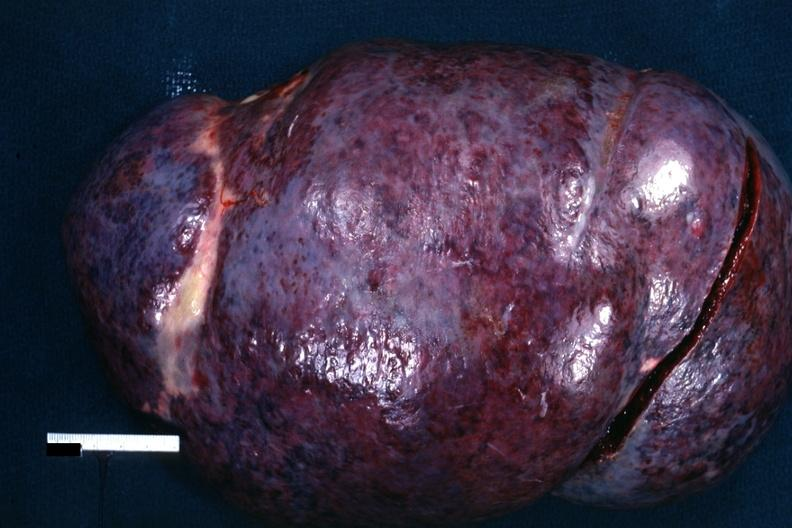s autoimmune thyroiditis present?
Answer the question using a single word or phrase. No 